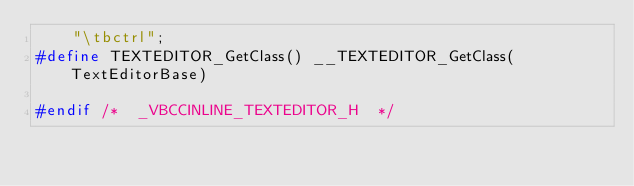Convert code to text. <code><loc_0><loc_0><loc_500><loc_500><_C_>	"\tbctrl";
#define TEXTEDITOR_GetClass() __TEXTEDITOR_GetClass(TextEditorBase)

#endif /*  _VBCCINLINE_TEXTEDITOR_H  */
</code> 